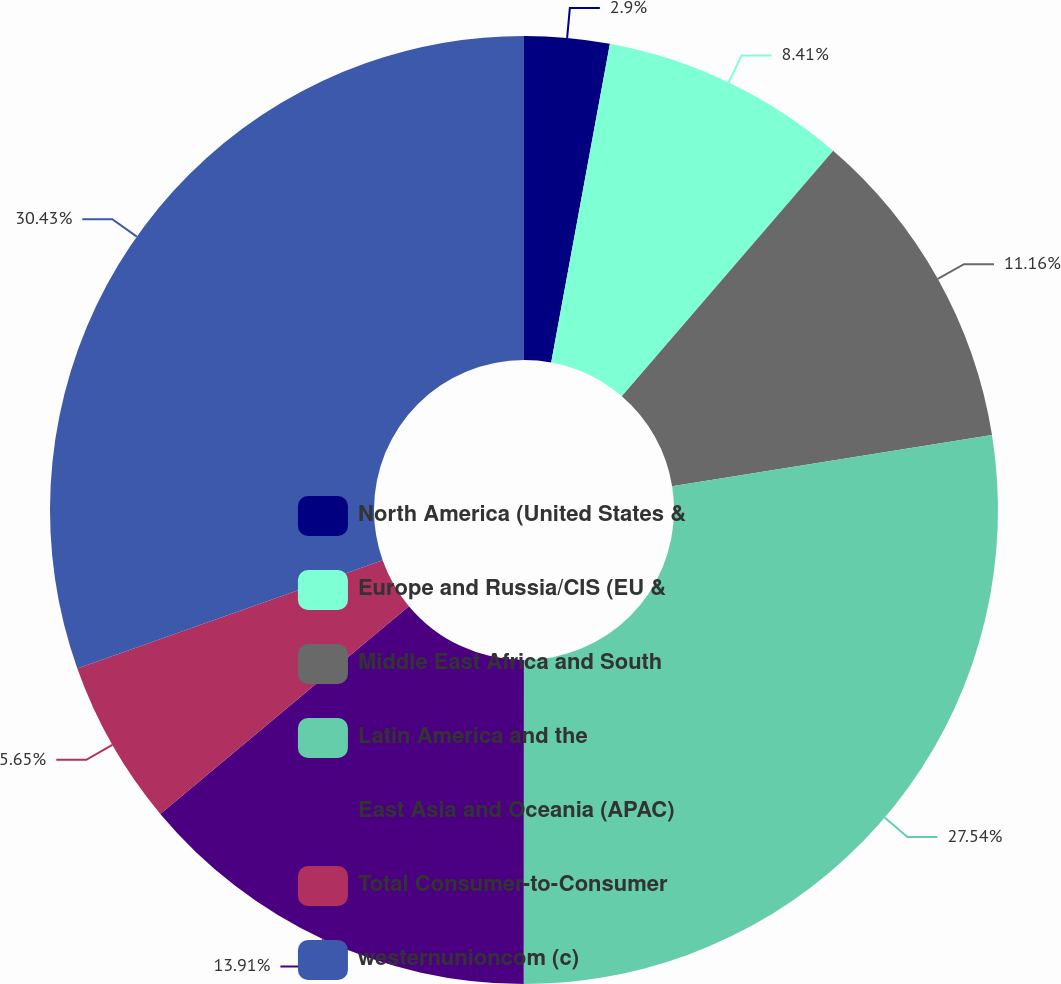Convert chart to OTSL. <chart><loc_0><loc_0><loc_500><loc_500><pie_chart><fcel>North America (United States &<fcel>Europe and Russia/CIS (EU &<fcel>Middle East Africa and South<fcel>Latin America and the<fcel>East Asia and Oceania (APAC)<fcel>Total Consumer-to-Consumer<fcel>westernunioncom (c)<nl><fcel>2.9%<fcel>8.41%<fcel>11.16%<fcel>27.54%<fcel>13.91%<fcel>5.65%<fcel>30.43%<nl></chart> 